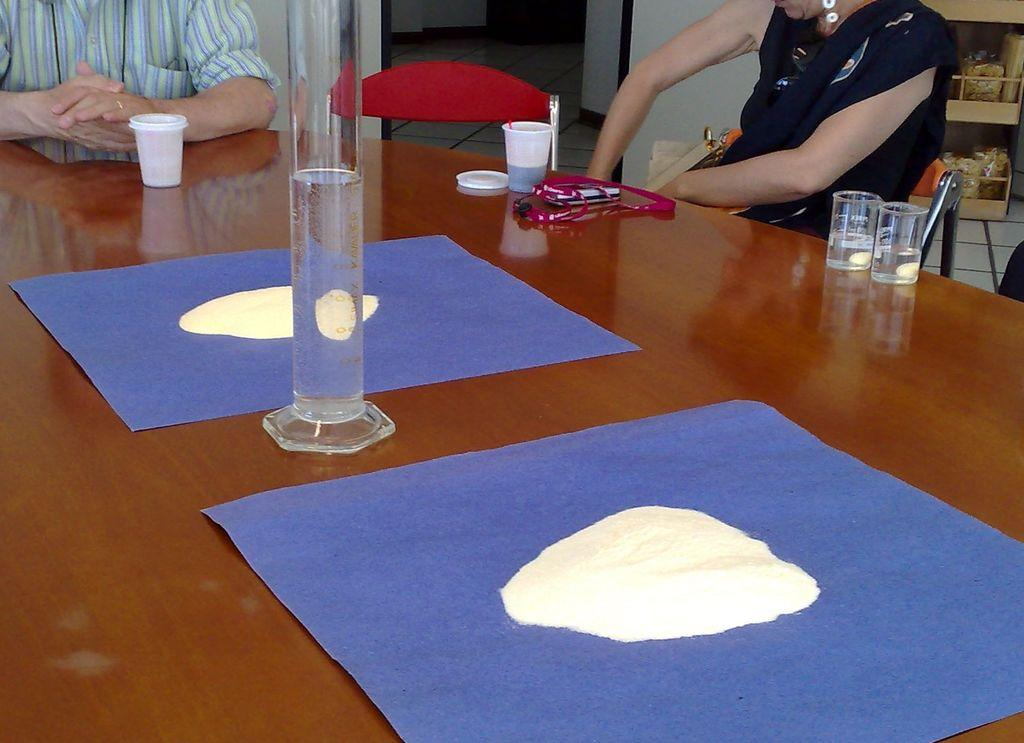What object is on the table in the image? There is a glass on a table in the image. Are there any people present in the image? Yes, there are people near the table in the image. What type of brass instrument is being played by the people near the table? There is no brass instrument or indication of music in the image; it only shows a glass on a table and people near the table. 